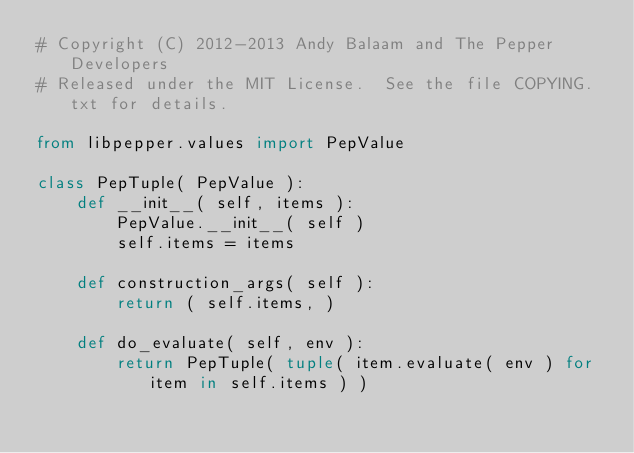Convert code to text. <code><loc_0><loc_0><loc_500><loc_500><_Python_># Copyright (C) 2012-2013 Andy Balaam and The Pepper Developers
# Released under the MIT License.  See the file COPYING.txt for details.

from libpepper.values import PepValue

class PepTuple( PepValue ):
    def __init__( self, items ):
        PepValue.__init__( self )
        self.items = items

    def construction_args( self ):
        return ( self.items, )

    def do_evaluate( self, env ):
        return PepTuple( tuple( item.evaluate( env ) for item in self.items ) )

</code> 